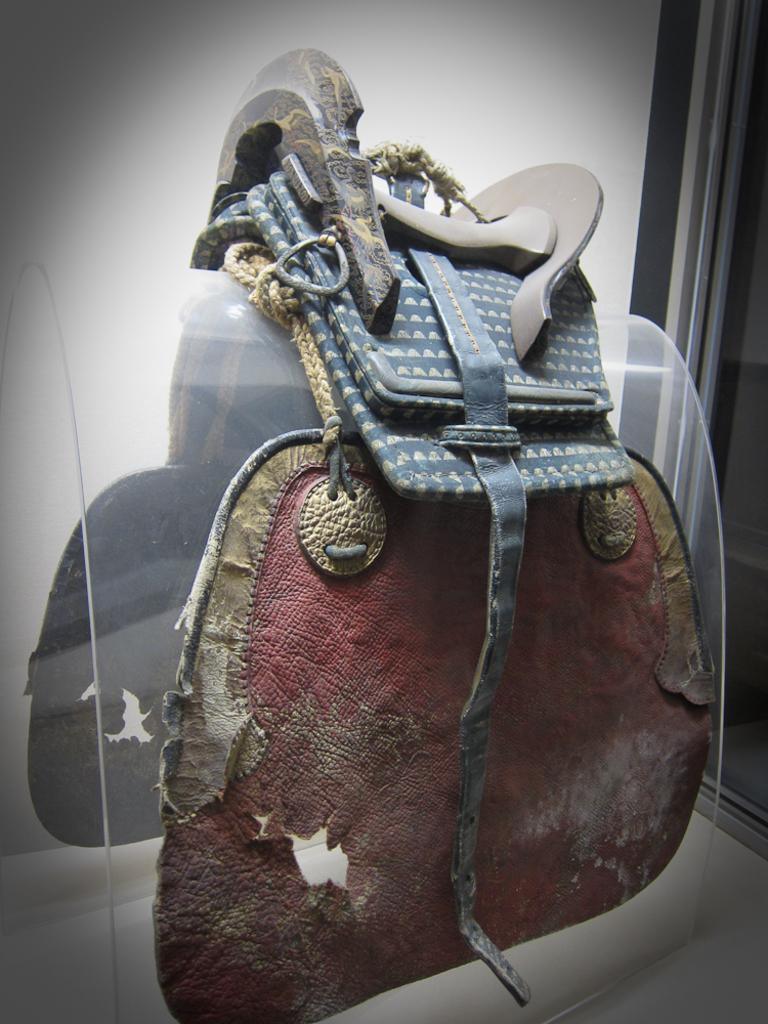Please provide a concise description of this image. This is a latigo carrier and it is placed as a tack on horse. 